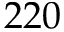Convert formula to latex. <formula><loc_0><loc_0><loc_500><loc_500>2 2 0</formula> 